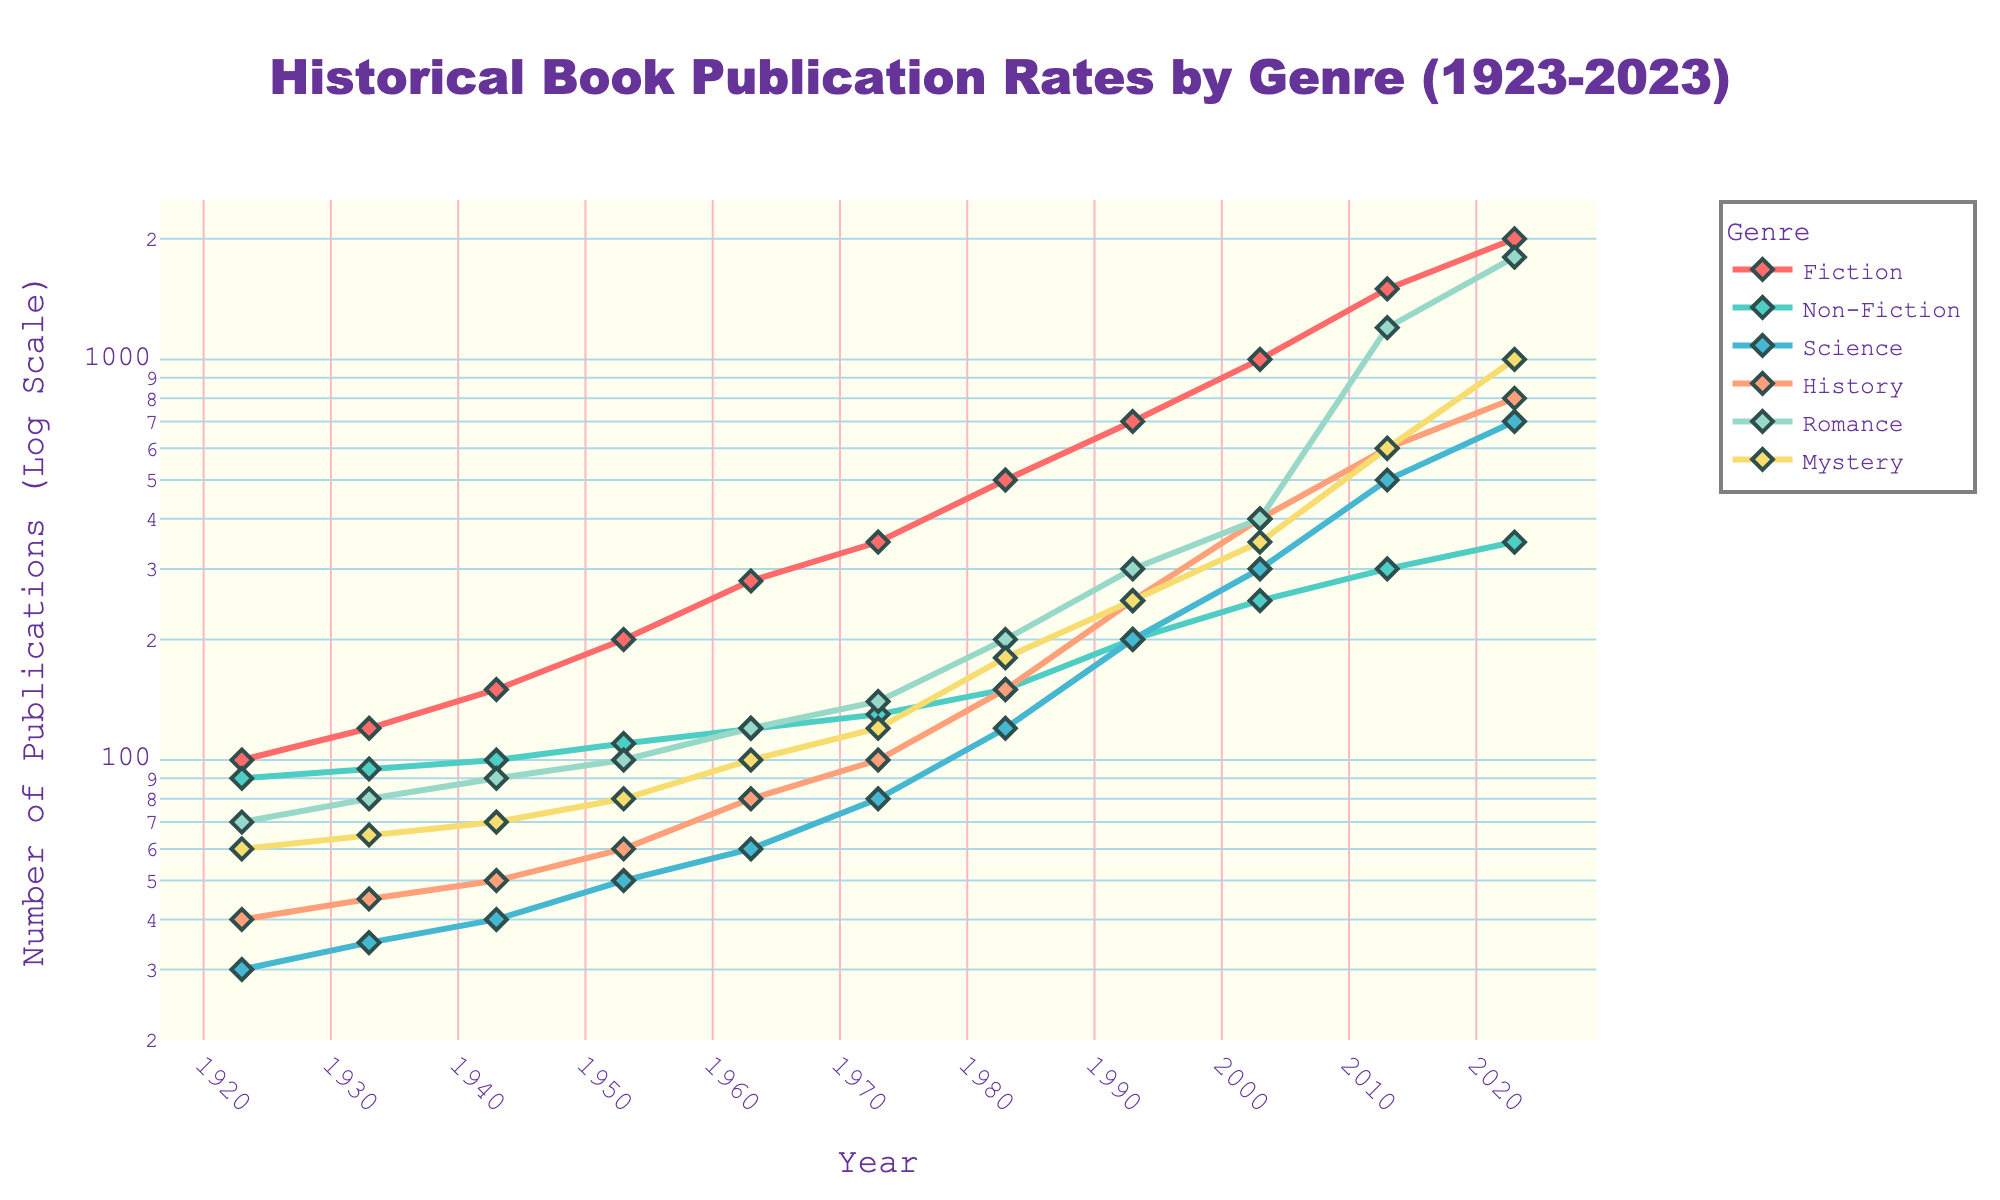what is the title of the plot? The title is located at the top of the figure, presenting an overview of what the plot depicts. It reads "Historical Book Publication Rates by Genre (1923-2023)."
Answer: Historical Book Publication Rates by Genre (1923-2023) what is the publication rate for Romance in 2023? Look at the line for Romance and at the intersection with the year 2023 on the x-axis. The y-axis value corresponding to this point indicates the publication rate for Romance, which is at 1800.
Answer: 1800 which genre had the highest publication rate in 1983? Locate the year 1983 on the x-axis, then look at the y-values for all genres. The highest value is for Fiction, which had a publication rate of 500.
Answer: Fiction when did Science publications start to rapidly increase? By examining the Science line, identify the point where the slope of the curve becomes significantly steeper. Rapid growth is noticeable starting around 1973, where it goes from 80 to 150 publications by 1983.
Answer: Around 1973 how does the publication rate of Mystery in 2023 compare to Fiction in 1953? Find the publication rate for Mystery in 2023 (1000) and Fiction in 1953 (200). Compare the two: 1000 is greater than 200.
Answer: Mystery in 2023 is greater what is the difference in publication numbers between Non-Fiction and Science in the year 2003? Locate the publication rates for Non-Fiction (250) and Science (300) in 2003. The difference is 300 - 250 = 50.
Answer: 50 which genre shows the most exponential growth over the entire century? Examine the lines and observe the genre that displays the steepest overall increase. Romance shows a significant exponential growth, from 70 in 1923 to 1800 in 2023.
Answer: Romance what was the publication rate of History in 1993, and how does it compare to the rate in 1983? Find the publication rates for History in 1993 (250) and 1983 (150). 250 is higher than 150, so it increased by 100.
Answer: 250 in 1993, 100 more than 1983 which genres had their publication rates double at some point between 1923 and 2023? Check each genre's line and identify where a genre's publication rate doubled from an earlier point. Both Fiction (700 -> 1500 from 1993 to 2013) and Non-Fiction (150 -> 300 from 1983 to 2013) doubled at different times.
Answer: Fiction and Non-Fiction is the y-axis in a linear or logarithmic scale, and what does it imply? The y-axis is indicated as "Number of Publications (Log Scale)," showing it’s in logarithmic form. This means each tick mark represents an exponential increase in publication numbers, making it easier to see relative growth across different orders of magnitude.
Answer: Logarithmic scale 